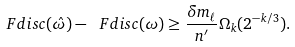<formula> <loc_0><loc_0><loc_500><loc_500>\ F d i s c ( \hat { \omega } ) - \ F d i s c ( \omega ) \geq \frac { \delta m _ { \ell } } { n ^ { \prime } } \Omega _ { k } ( 2 ^ { - k / 3 } ) .</formula> 